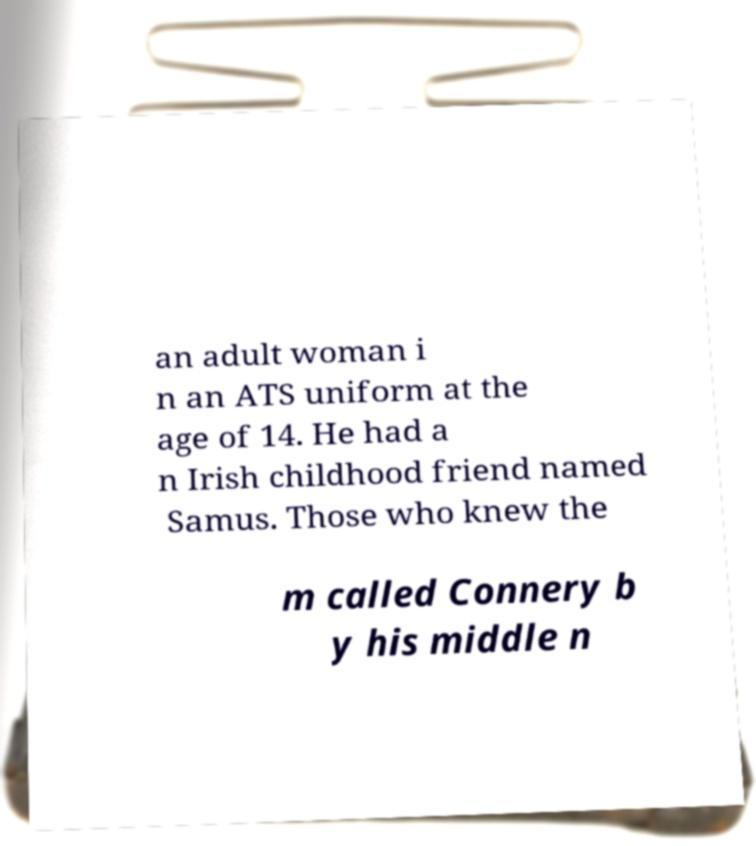Could you assist in decoding the text presented in this image and type it out clearly? an adult woman i n an ATS uniform at the age of 14. He had a n Irish childhood friend named Samus. Those who knew the m called Connery b y his middle n 